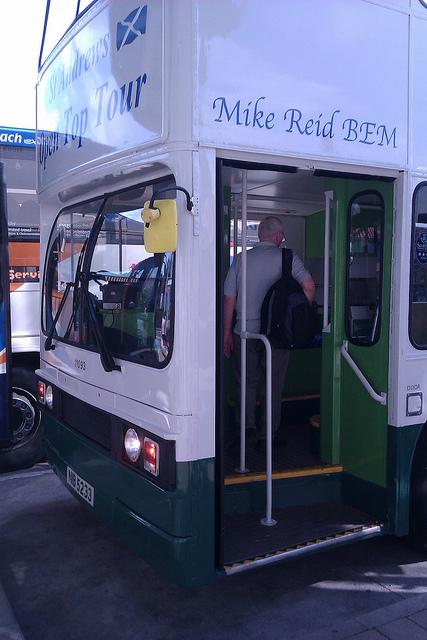What country is this?
Keep it brief. England. What is the man in the gray shirt holding on his back?
Quick response, please. Backpack. Is this bus in motion?
Concise answer only. No. 